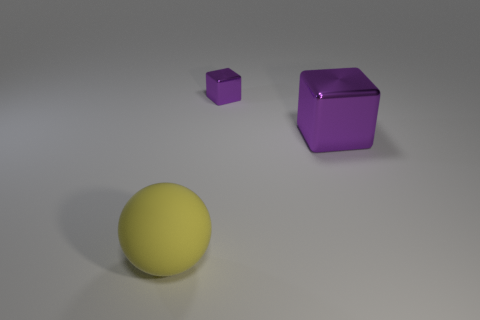Is the large matte object the same color as the tiny shiny cube?
Give a very brief answer. No. Are there fewer tiny purple metallic things than cyan metallic blocks?
Provide a succinct answer. No. There is a big thing to the right of the large yellow rubber thing; are there any purple blocks that are to the left of it?
Keep it short and to the point. Yes. There is a object that is the same material as the small block; what shape is it?
Make the answer very short. Cube. Is there anything else that is the same color as the rubber object?
Provide a short and direct response. No. How many other things are the same size as the sphere?
Provide a short and direct response. 1. There is a metallic cube that is the same color as the tiny thing; what size is it?
Your response must be concise. Large. Do the purple thing that is to the left of the big purple shiny cube and the large purple thing have the same shape?
Make the answer very short. Yes. What number of other things are the same shape as the large metallic thing?
Give a very brief answer. 1. What is the shape of the large object that is behind the yellow rubber object?
Make the answer very short. Cube. 